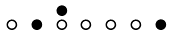Convert formula to latex. <formula><loc_0><loc_0><loc_500><loc_500>\begin{smallmatrix} & & \bullet \\ \circ & \bullet & \circ & \circ & \circ & \circ & \bullet & \\ \end{smallmatrix}</formula> 